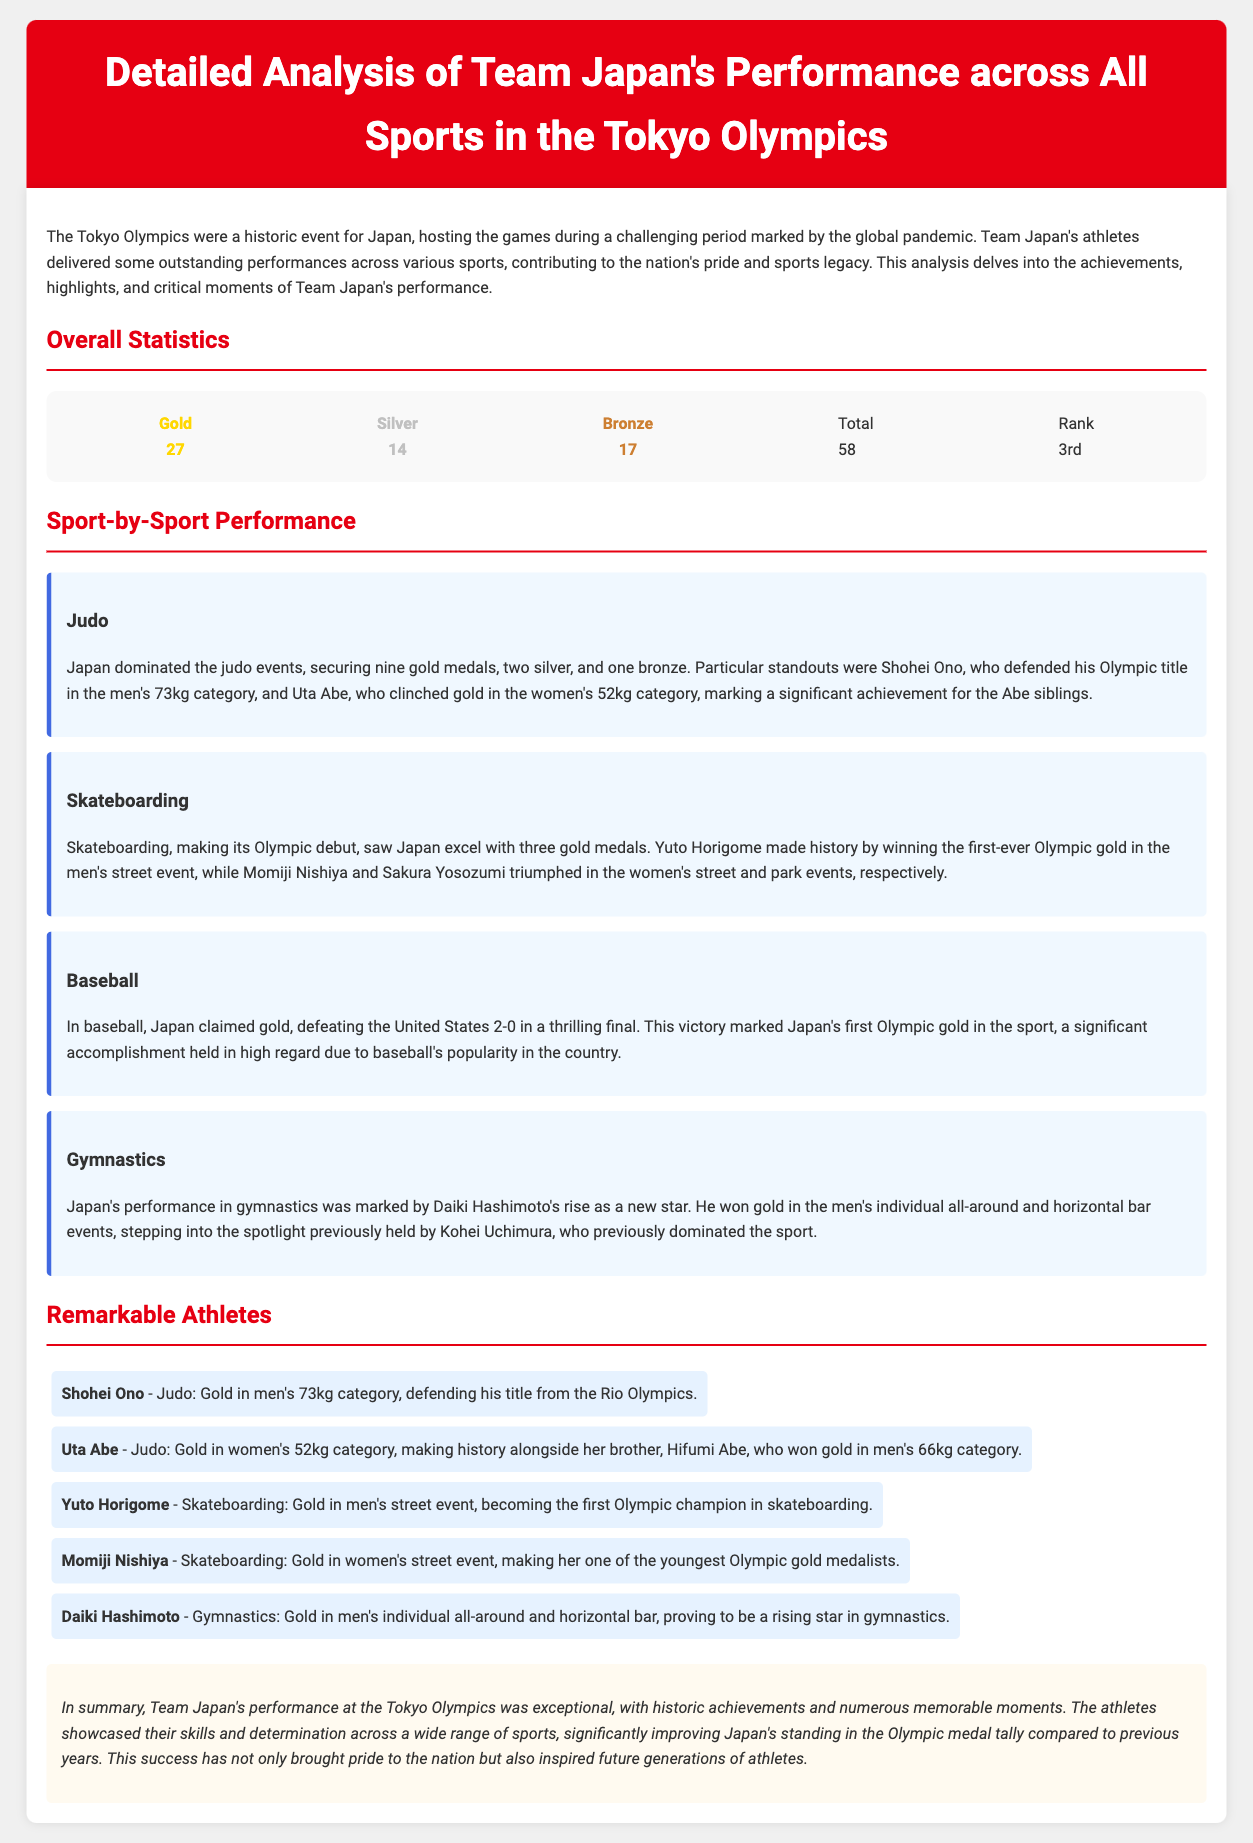what was Japan's total medal count? The document states that Team Japan won a total of 58 medals at the Tokyo Olympics, including gold, silver, and bronze.
Answer: 58 how many gold medals did Japan win in judo? The analysis highlights that Japan secured nine gold medals specifically in judo events.
Answer: 9 who won gold in the men's street skateboarding event? The document mentions that Yuto Horigome made history by winning gold in the men's street event.
Answer: Yuto Horigome what was Japan's rank in the overall medal tally? According to the document, Japan ranked 3rd in the overall medal tally at the Tokyo Olympics.
Answer: 3rd how many silver medals did Japan achieve? The document notes that Japan won a total of 14 silver medals during the Tokyo Olympics.
Answer: 14 which athlete defended their Olympic title in judo? The document indicates that Shohei Ono defended his Olympic title in the men's 73kg category.
Answer: Shohei Ono what significant achievement did Japan accomplish in baseball? The analysis states that Japan claimed gold in baseball, marking their first Olympic gold in the sport.
Answer: First Olympic gold how many gold medals did Japan win in skateboarding? The document reports that Japan excelled in skateboarding with three gold medals.
Answer: 3 who emerged as a new star in gymnastics? The performance analysis highlights that Daiki Hashimoto rose as a new star in gymnastics with his outstanding achievements.
Answer: Daiki Hashimoto 